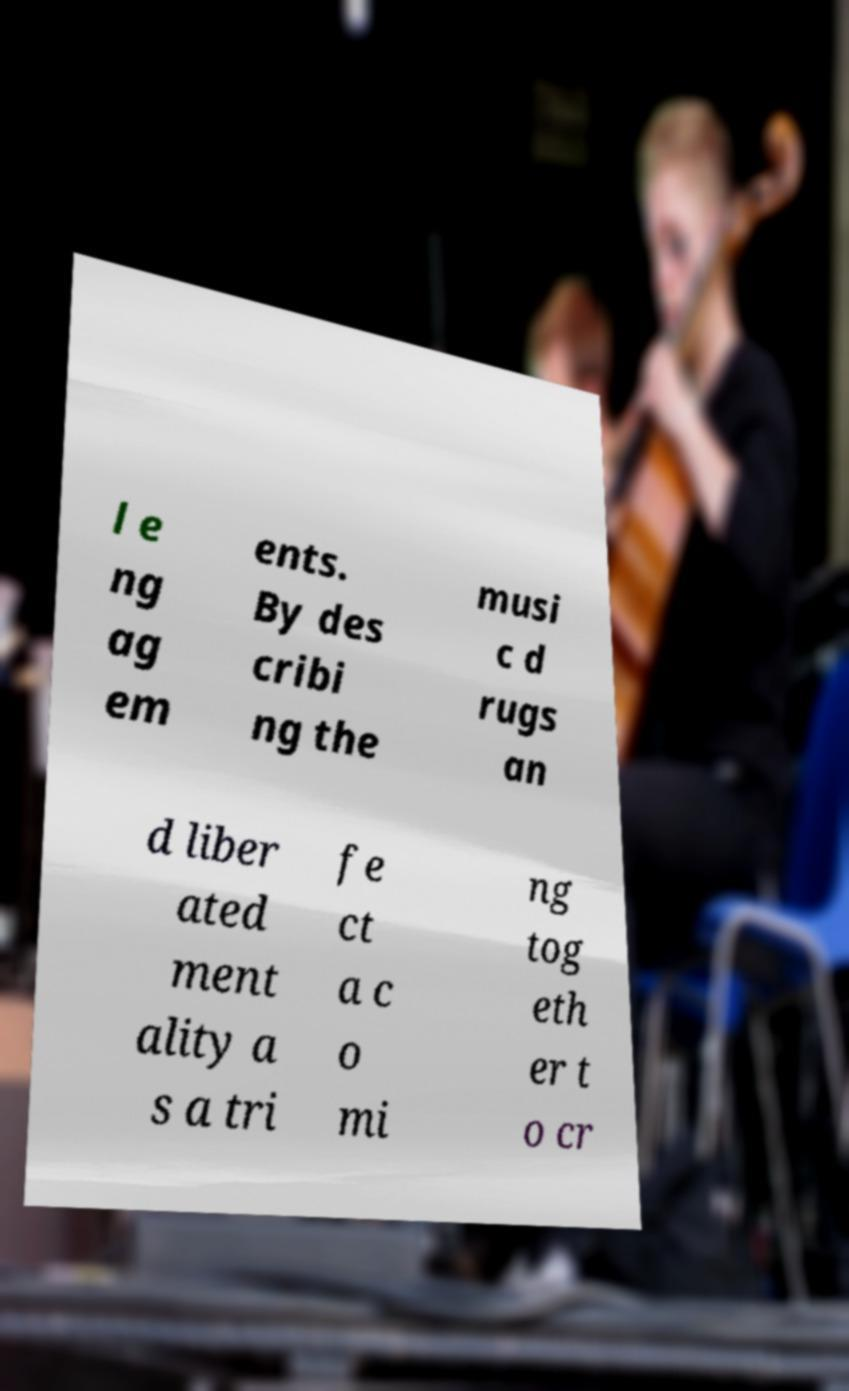Please identify and transcribe the text found in this image. l e ng ag em ents. By des cribi ng the musi c d rugs an d liber ated ment ality a s a tri fe ct a c o mi ng tog eth er t o cr 